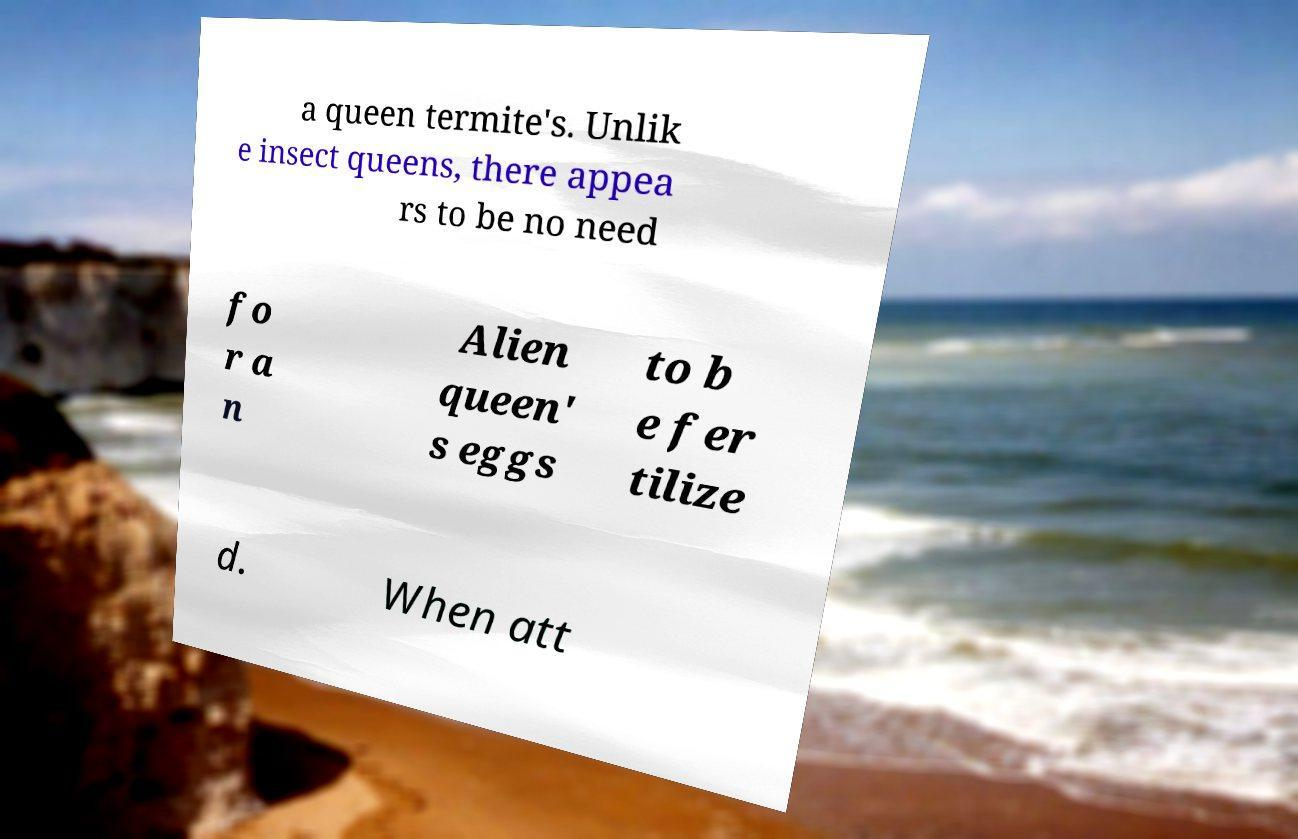I need the written content from this picture converted into text. Can you do that? a queen termite's. Unlik e insect queens, there appea rs to be no need fo r a n Alien queen' s eggs to b e fer tilize d. When att 